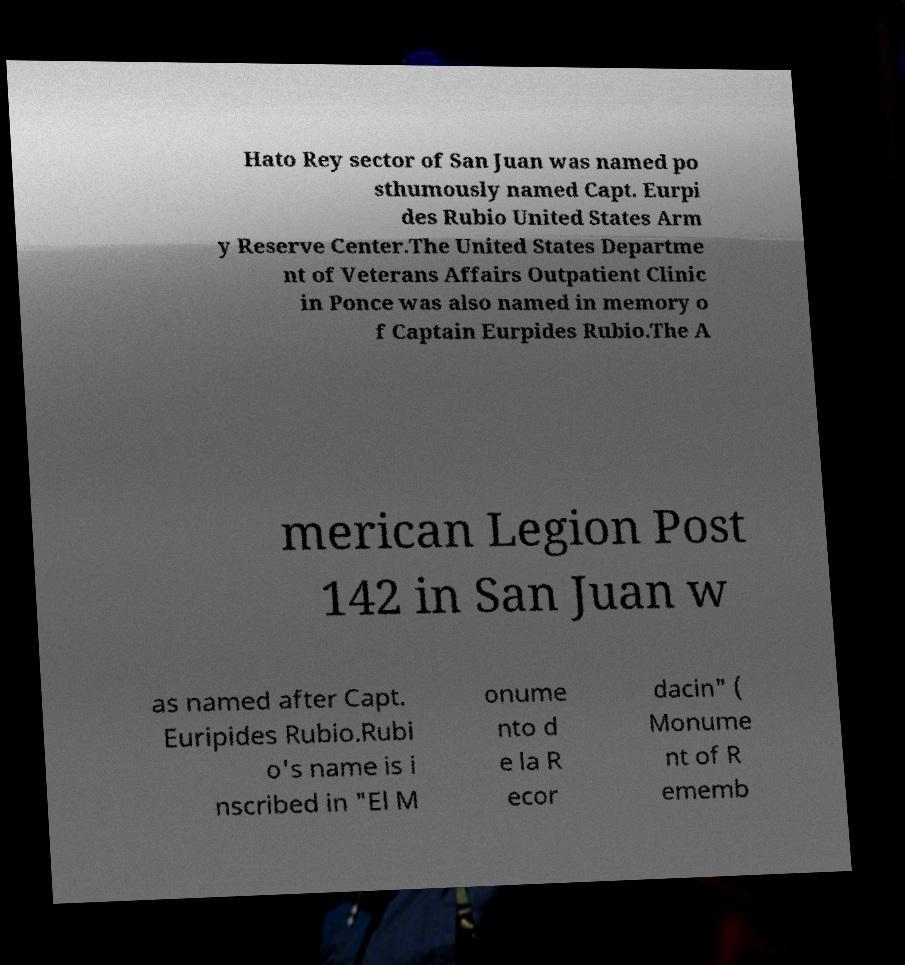I need the written content from this picture converted into text. Can you do that? Hato Rey sector of San Juan was named po sthumously named Capt. Eurpi des Rubio United States Arm y Reserve Center.The United States Departme nt of Veterans Affairs Outpatient Clinic in Ponce was also named in memory o f Captain Eurpides Rubio.The A merican Legion Post 142 in San Juan w as named after Capt. Euripides Rubio.Rubi o's name is i nscribed in "El M onume nto d e la R ecor dacin" ( Monume nt of R ememb 